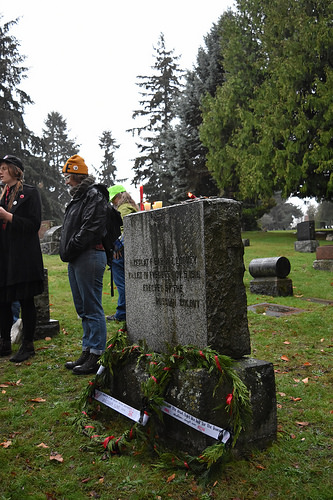<image>
Is there a person in front of the grave? No. The person is not in front of the grave. The spatial positioning shows a different relationship between these objects. 